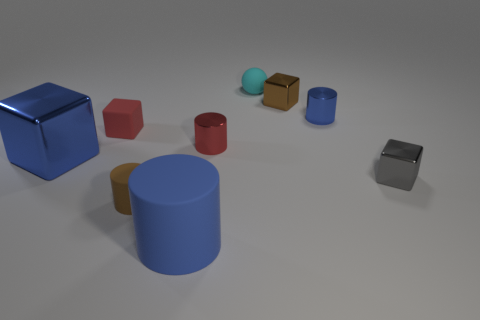Add 1 red shiny balls. How many objects exist? 10 Subtract all balls. How many objects are left? 8 Subtract all tiny red cylinders. Subtract all red matte things. How many objects are left? 7 Add 9 tiny brown cubes. How many tiny brown cubes are left? 10 Add 8 small shiny cylinders. How many small shiny cylinders exist? 10 Subtract 1 brown blocks. How many objects are left? 8 